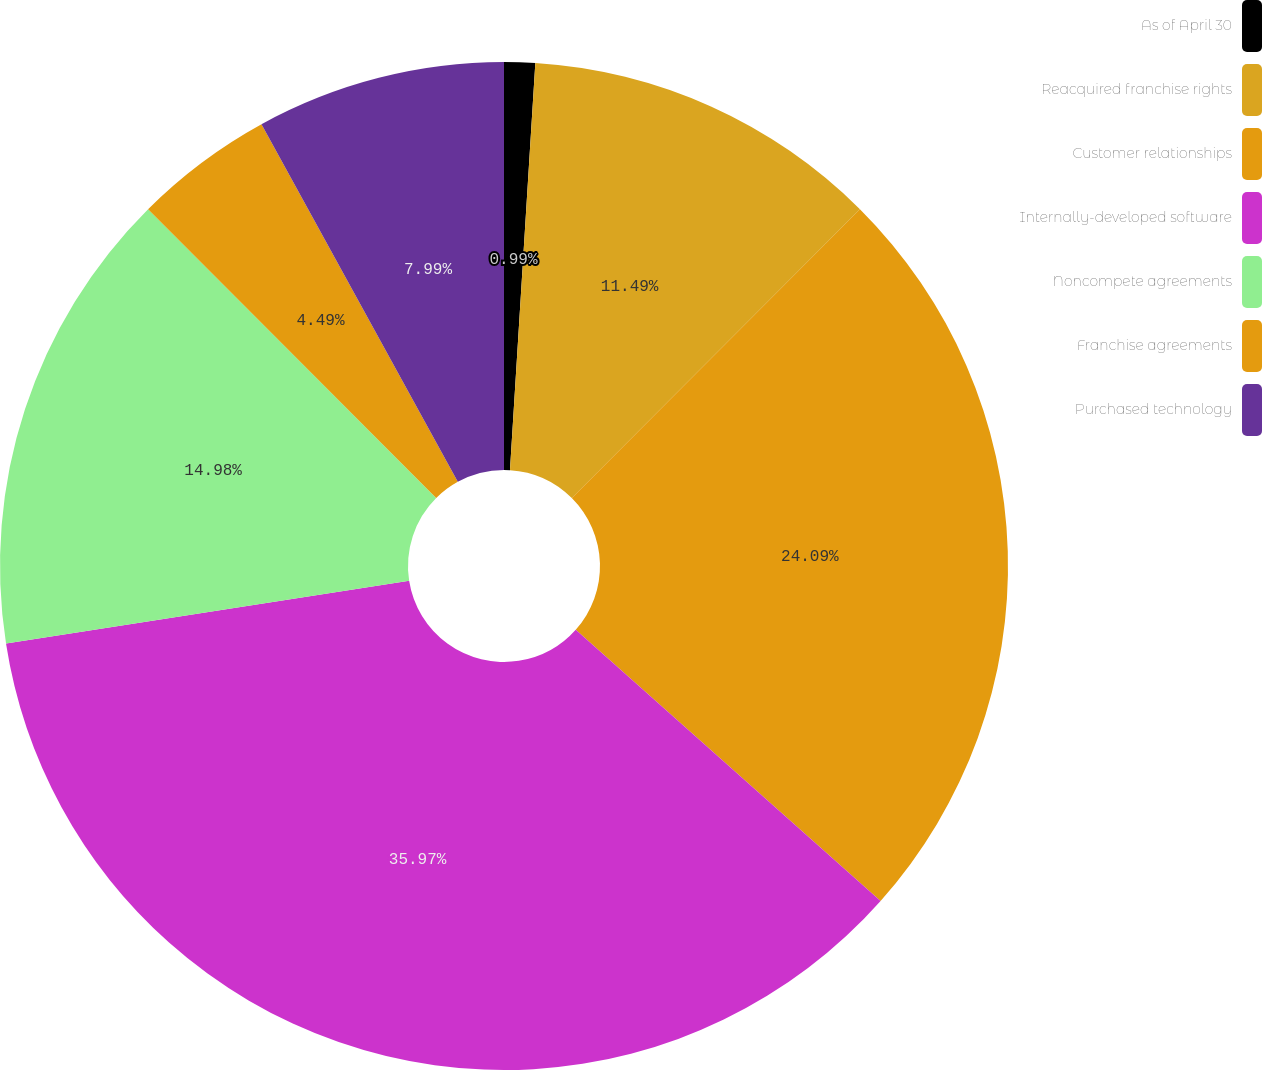Convert chart. <chart><loc_0><loc_0><loc_500><loc_500><pie_chart><fcel>As of April 30<fcel>Reacquired franchise rights<fcel>Customer relationships<fcel>Internally-developed software<fcel>Noncompete agreements<fcel>Franchise agreements<fcel>Purchased technology<nl><fcel>0.99%<fcel>11.49%<fcel>24.09%<fcel>35.97%<fcel>14.98%<fcel>4.49%<fcel>7.99%<nl></chart> 